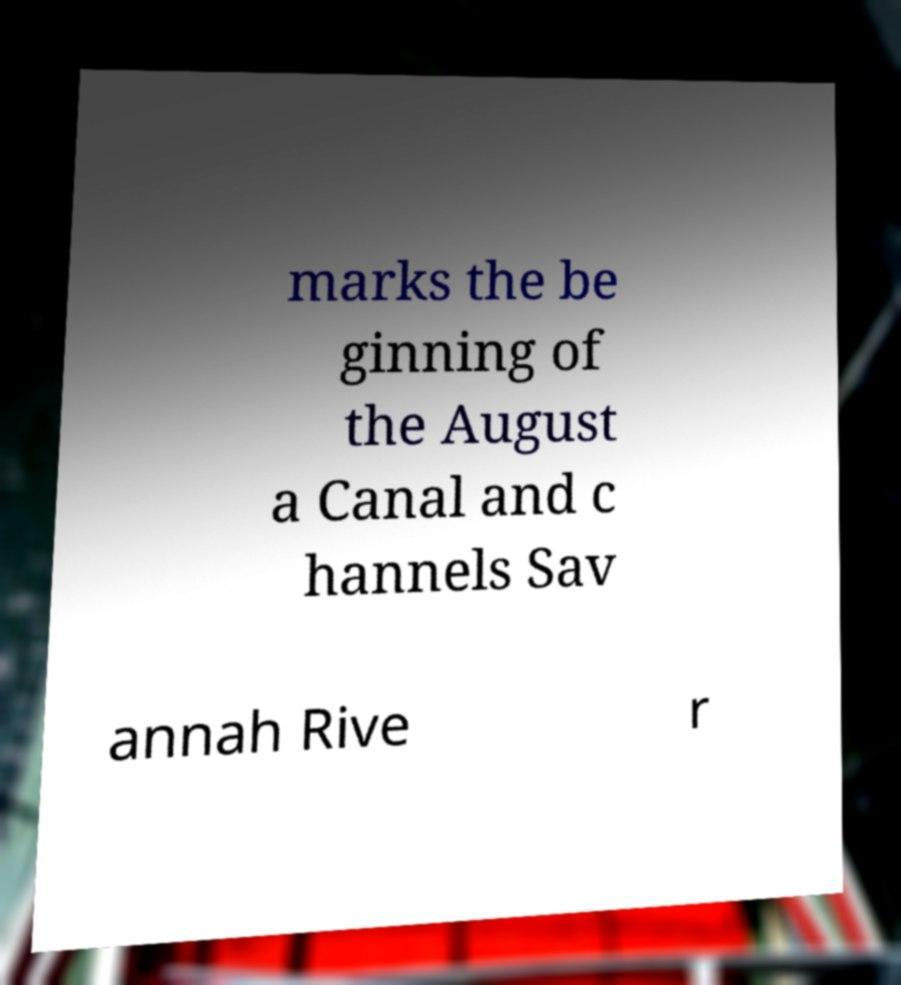What messages or text are displayed in this image? I need them in a readable, typed format. marks the be ginning of the August a Canal and c hannels Sav annah Rive r 